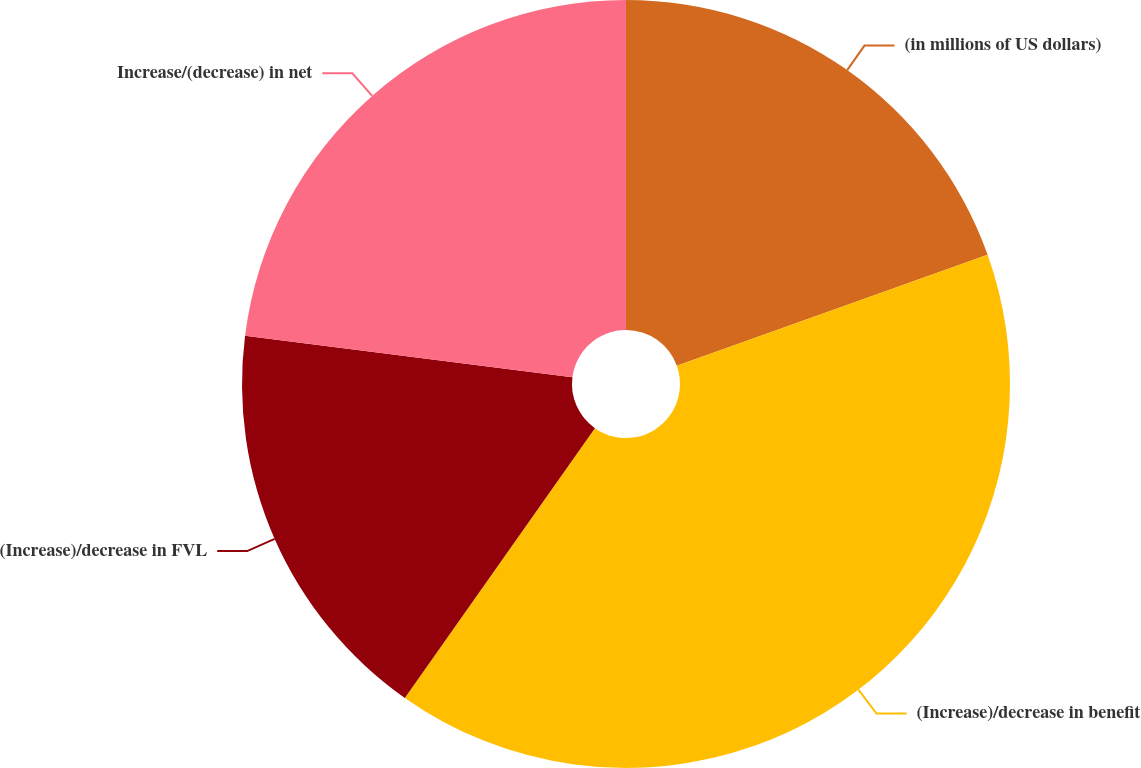Convert chart. <chart><loc_0><loc_0><loc_500><loc_500><pie_chart><fcel>(in millions of US dollars)<fcel>(Increase)/decrease in benefit<fcel>(Increase)/decrease in FVL<fcel>Increase/(decrease) in net<nl><fcel>19.54%<fcel>40.23%<fcel>17.24%<fcel>22.99%<nl></chart> 